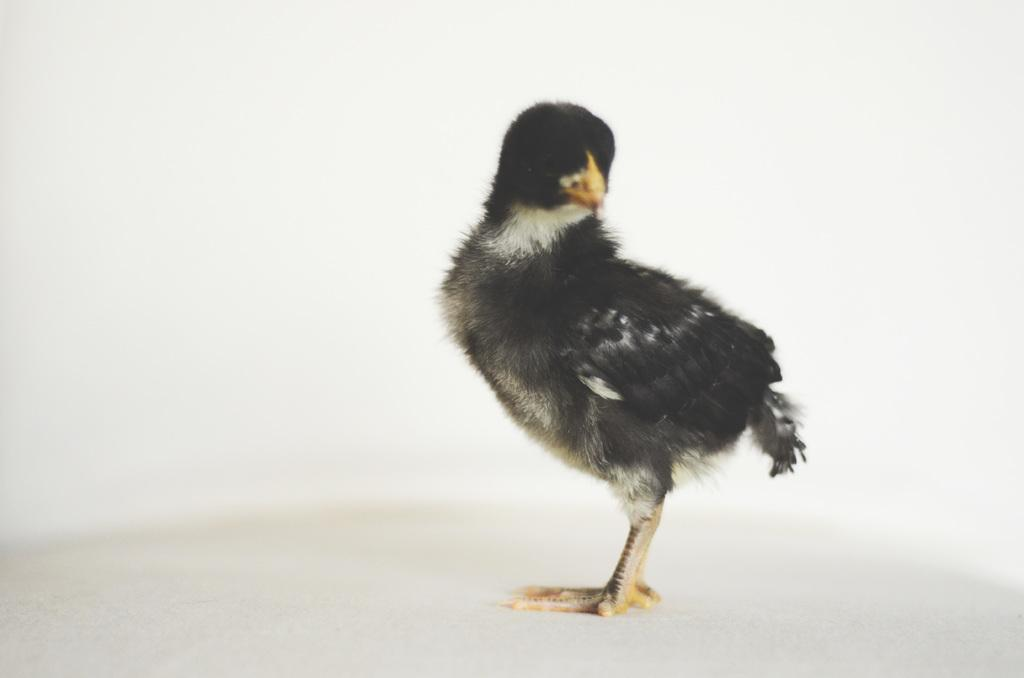What type of animal is in the image? There is a bird in the image. What colors can be seen on the bird? The bird has white and black colors. What color is the background of the image? The background of the image is white. How does the bird feel about the weather in the image? There is no information about the weather in the image, so we cannot determine how the bird feels about it. 